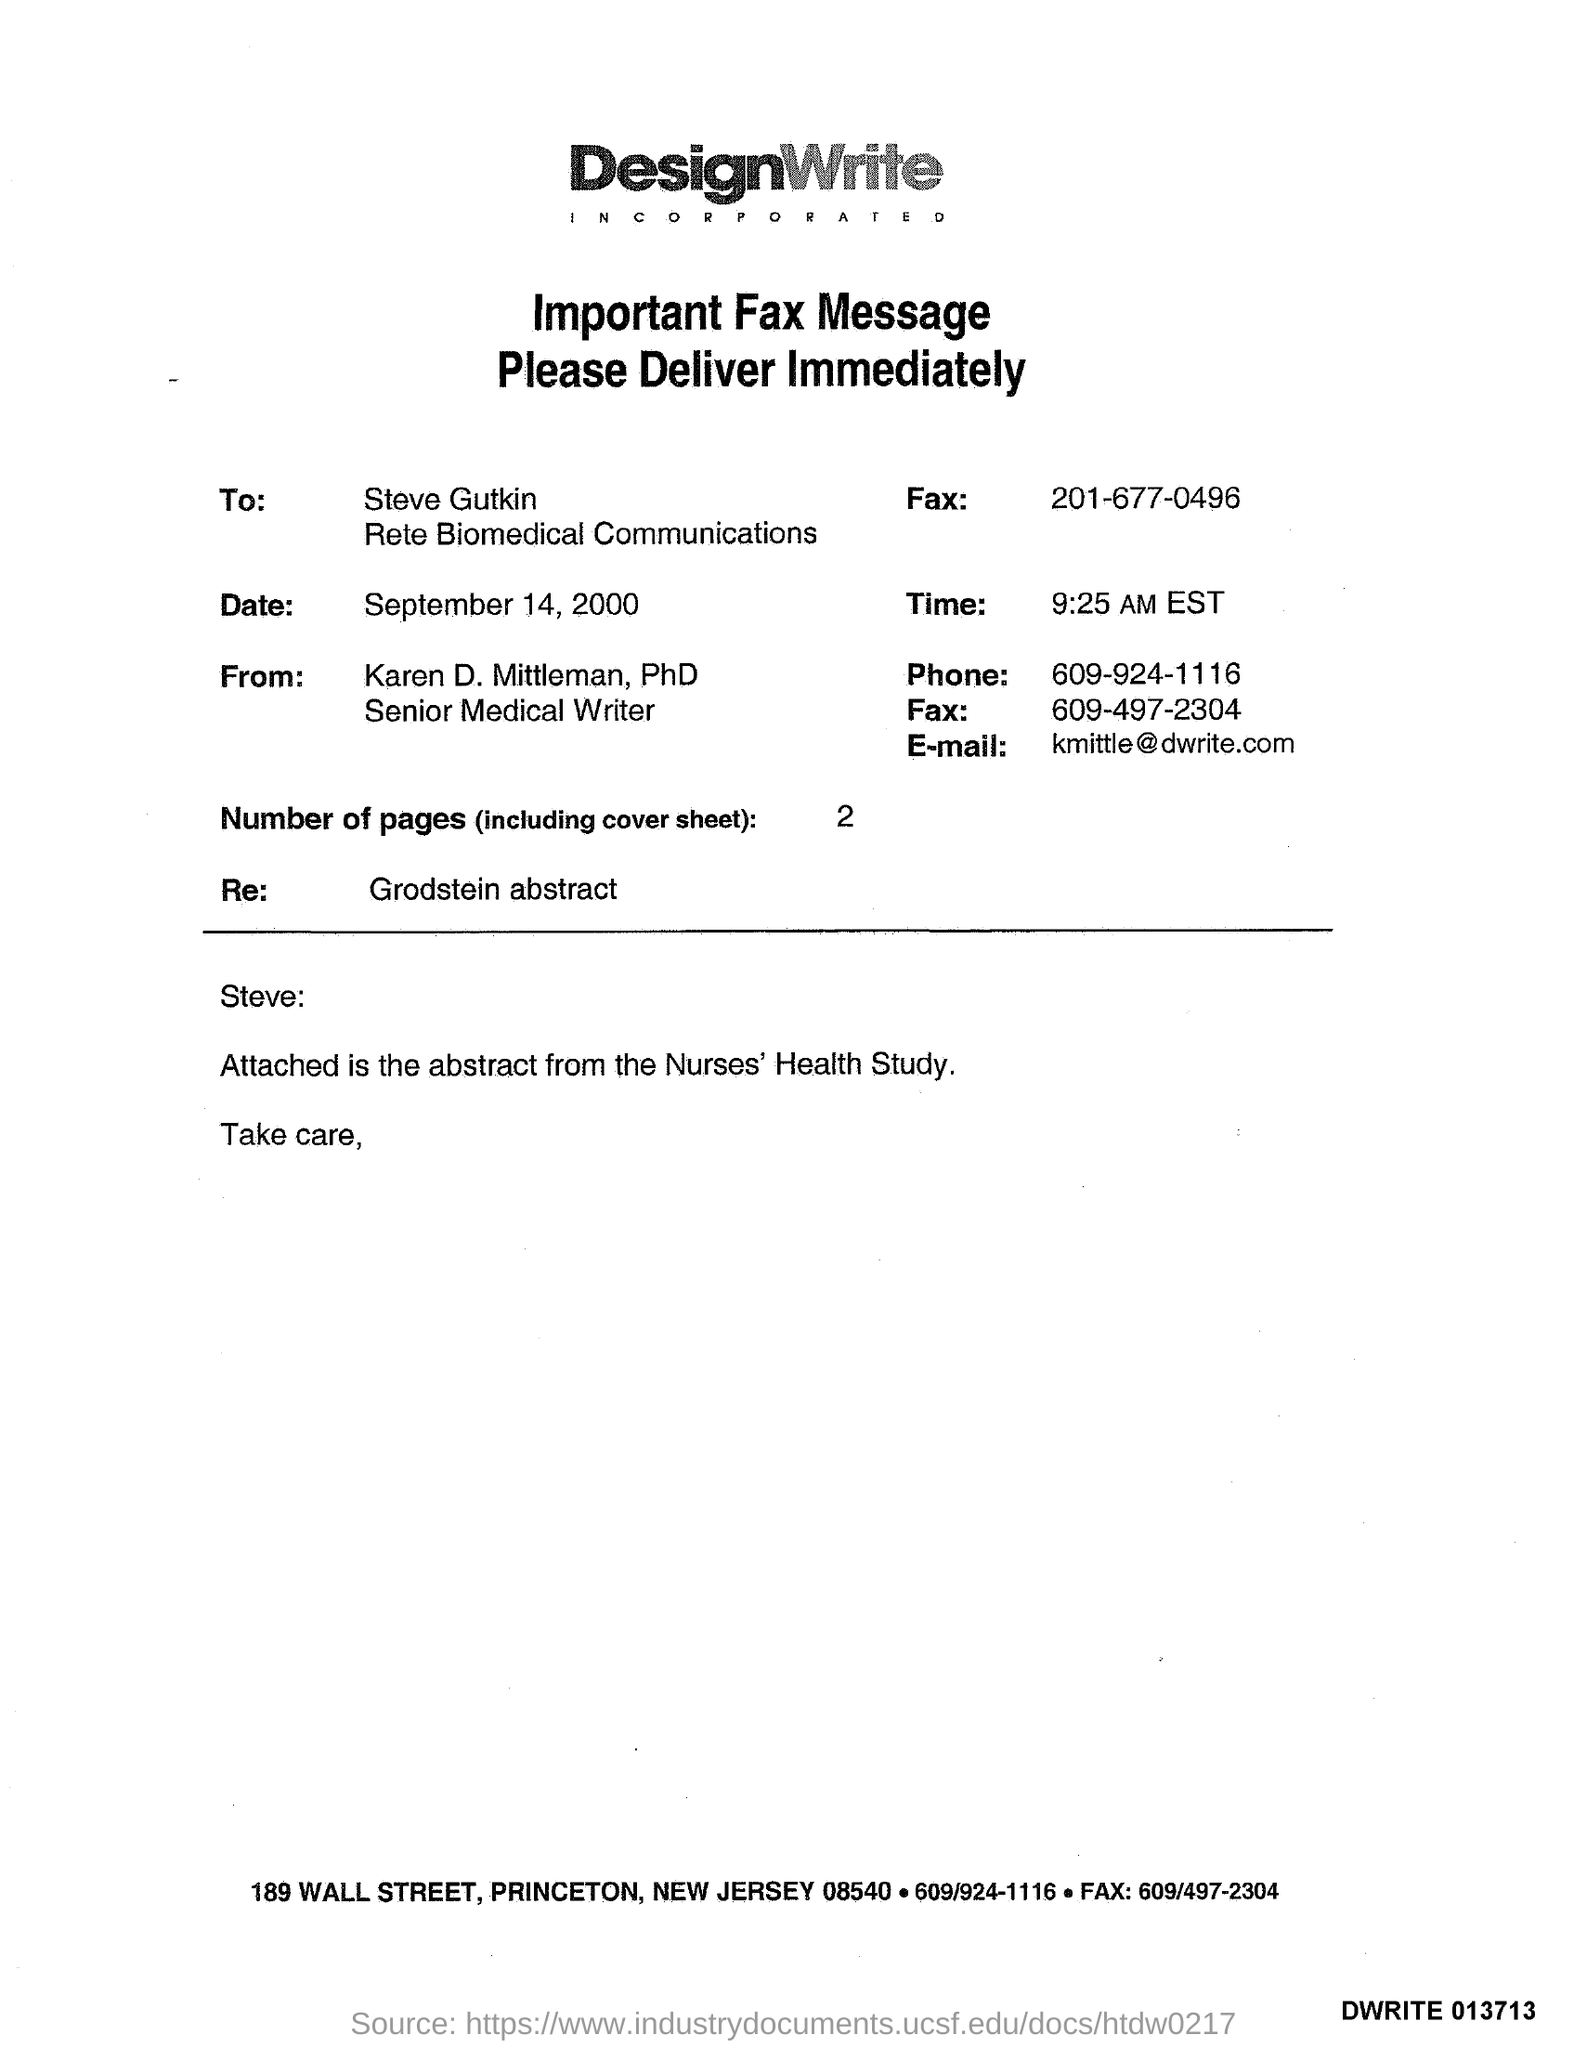Draw attention to some important aspects in this diagram. It is currently 9:25 AM EST. Karen D. Mittleman, PhD, is the fax from. The date on the fax is September 14, 2000. The phone number is 609-924-1116. What is the 'Re:' in the Grodstein abstract?" is a question asking for information about a specific reference or citation in the abstract. 